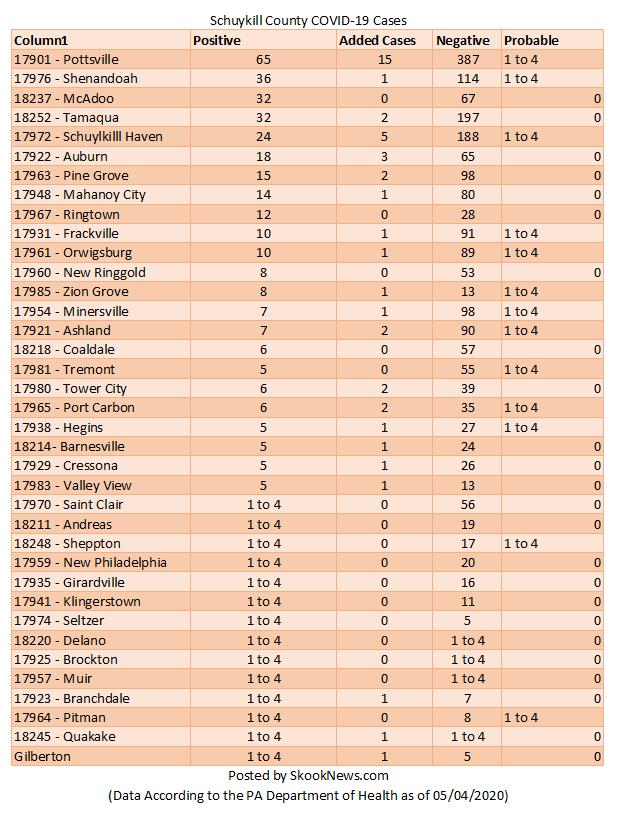Mention a couple of crucial points in this snapshot. As of 05/04/2020, there were two new cases of Covid-19 added in Tamaqua. There were three new cases of Covid-19 added in Auburn as of 05/04/2020. As of April 5, 2020, the number of reported Covid-negative cases in Valley View was 1. As of April 5, 2020, the number of COVID-19 cases reported in Ringtown was 12. As of April 5th, 2020, there have been 35 reported cases of Covid-negative individuals in Port Carbon. 